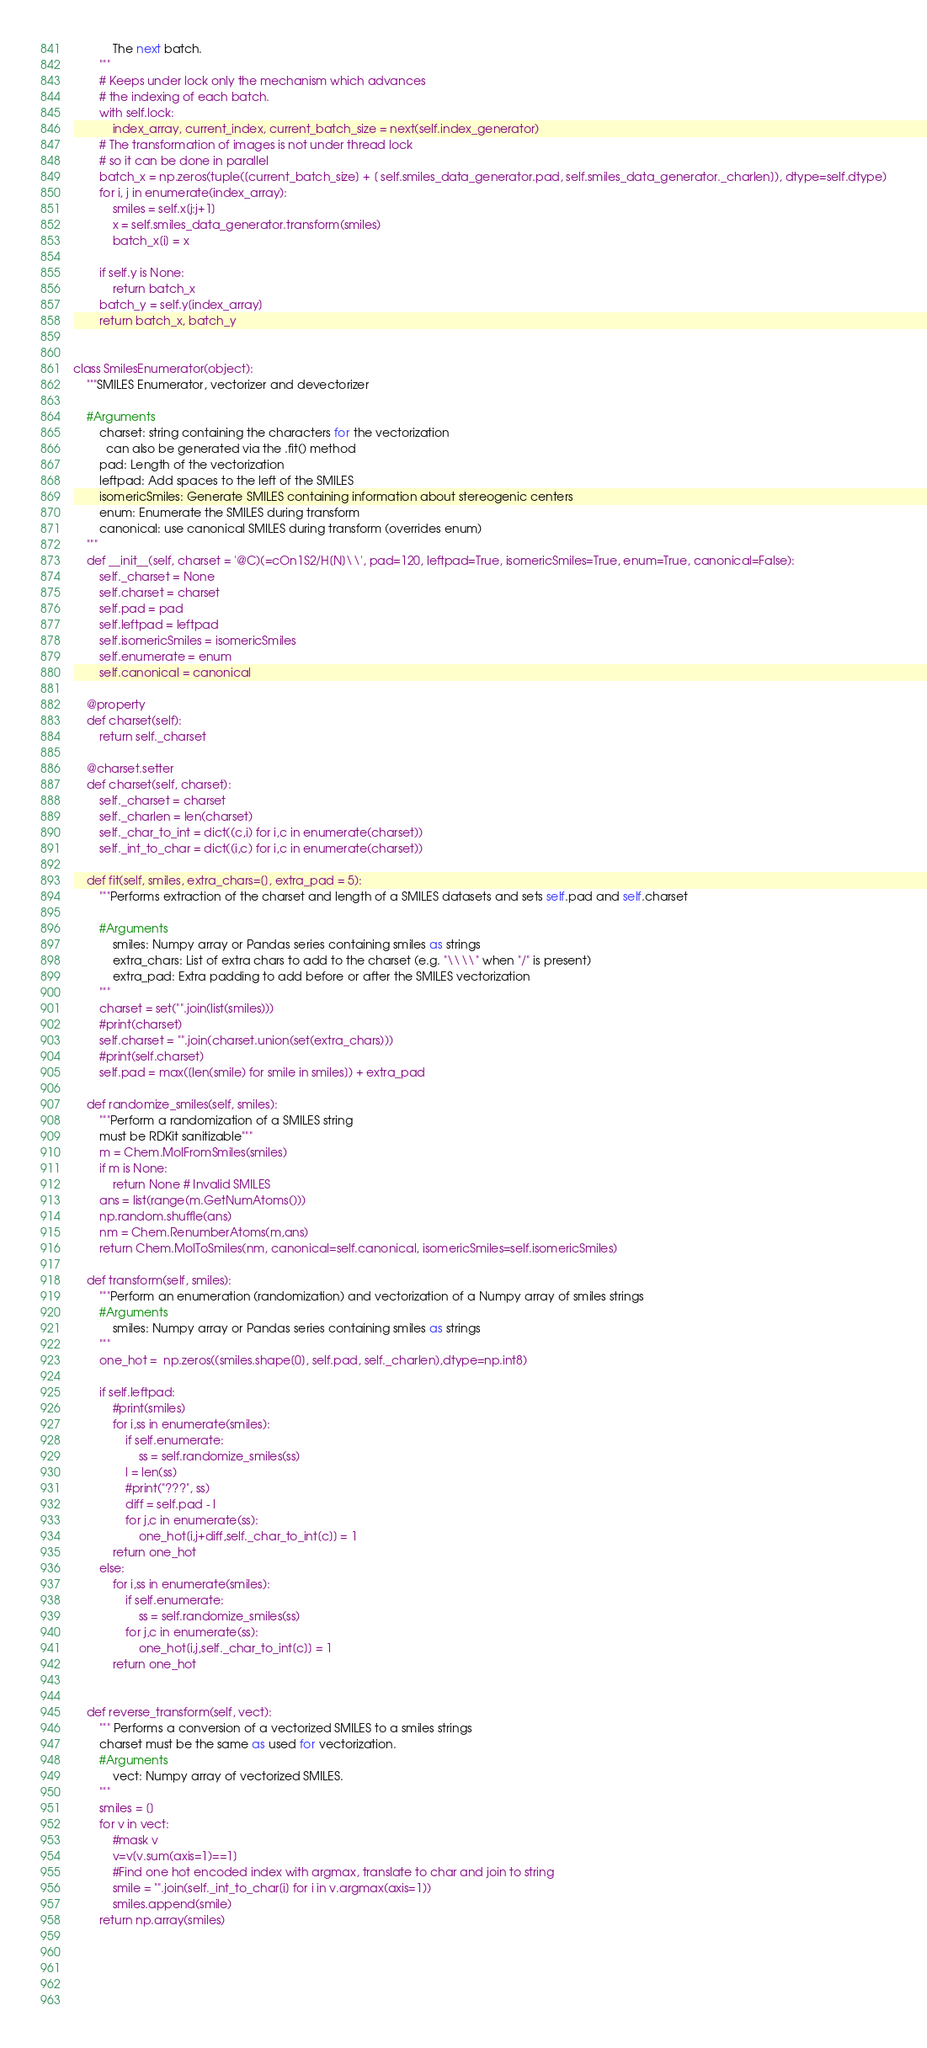<code> <loc_0><loc_0><loc_500><loc_500><_Python_>            The next batch.
        """
        # Keeps under lock only the mechanism which advances
        # the indexing of each batch.
        with self.lock:
            index_array, current_index, current_batch_size = next(self.index_generator)
        # The transformation of images is not under thread lock
        # so it can be done in parallel
        batch_x = np.zeros(tuple([current_batch_size] + [ self.smiles_data_generator.pad, self.smiles_data_generator._charlen]), dtype=self.dtype)
        for i, j in enumerate(index_array):
            smiles = self.x[j:j+1]
            x = self.smiles_data_generator.transform(smiles)
            batch_x[i] = x

        if self.y is None:
            return batch_x
        batch_y = self.y[index_array]
        return batch_x, batch_y


class SmilesEnumerator(object):
    """SMILES Enumerator, vectorizer and devectorizer
    
    #Arguments
        charset: string containing the characters for the vectorization
          can also be generated via the .fit() method
        pad: Length of the vectorization
        leftpad: Add spaces to the left of the SMILES
        isomericSmiles: Generate SMILES containing information about stereogenic centers
        enum: Enumerate the SMILES during transform
        canonical: use canonical SMILES during transform (overrides enum)
    """
    def __init__(self, charset = '@C)(=cOn1S2/H[N]\\', pad=120, leftpad=True, isomericSmiles=True, enum=True, canonical=False):
        self._charset = None
        self.charset = charset
        self.pad = pad
        self.leftpad = leftpad
        self.isomericSmiles = isomericSmiles
        self.enumerate = enum
        self.canonical = canonical

    @property
    def charset(self):
        return self._charset
        
    @charset.setter
    def charset(self, charset):
        self._charset = charset
        self._charlen = len(charset)
        self._char_to_int = dict((c,i) for i,c in enumerate(charset))
        self._int_to_char = dict((i,c) for i,c in enumerate(charset))
        
    def fit(self, smiles, extra_chars=[], extra_pad = 5):
        """Performs extraction of the charset and length of a SMILES datasets and sets self.pad and self.charset
        
        #Arguments
            smiles: Numpy array or Pandas series containing smiles as strings
            extra_chars: List of extra chars to add to the charset (e.g. "\\\\" when "/" is present)
            extra_pad: Extra padding to add before or after the SMILES vectorization
        """
        charset = set("".join(list(smiles)))
        #print(charset)
        self.charset = "".join(charset.union(set(extra_chars)))
        #print(self.charset)
        self.pad = max([len(smile) for smile in smiles]) + extra_pad
        
    def randomize_smiles(self, smiles):
        """Perform a randomization of a SMILES string
        must be RDKit sanitizable"""
        m = Chem.MolFromSmiles(smiles)
        if m is None:
            return None # Invalid SMILES
        ans = list(range(m.GetNumAtoms()))
        np.random.shuffle(ans)
        nm = Chem.RenumberAtoms(m,ans)
        return Chem.MolToSmiles(nm, canonical=self.canonical, isomericSmiles=self.isomericSmiles)

    def transform(self, smiles):
        """Perform an enumeration (randomization) and vectorization of a Numpy array of smiles strings
        #Arguments
            smiles: Numpy array or Pandas series containing smiles as strings
        """
        one_hot =  np.zeros((smiles.shape[0], self.pad, self._charlen),dtype=np.int8)
        
        if self.leftpad:
            #print(smiles)
            for i,ss in enumerate(smiles):
                if self.enumerate: 
                    ss = self.randomize_smiles(ss)
                l = len(ss)
                #print("???", ss)
                diff = self.pad - l
                for j,c in enumerate(ss):
                    one_hot[i,j+diff,self._char_to_int[c]] = 1
            return one_hot
        else:
            for i,ss in enumerate(smiles):
                if self.enumerate: 
                    ss = self.randomize_smiles(ss)
                for j,c in enumerate(ss):
                    one_hot[i,j,self._char_to_int[c]] = 1
            return one_hot

      
    def reverse_transform(self, vect):
        """ Performs a conversion of a vectorized SMILES to a smiles strings
        charset must be the same as used for vectorization.
        #Arguments
            vect: Numpy array of vectorized SMILES.
        """       
        smiles = []
        for v in vect:
            #mask v 
            v=v[v.sum(axis=1)==1]
            #Find one hot encoded index with argmax, translate to char and join to string
            smile = "".join(self._int_to_char[i] for i in v.argmax(axis=1))
            smiles.append(smile)
        return np.array(smiles)




        
</code> 